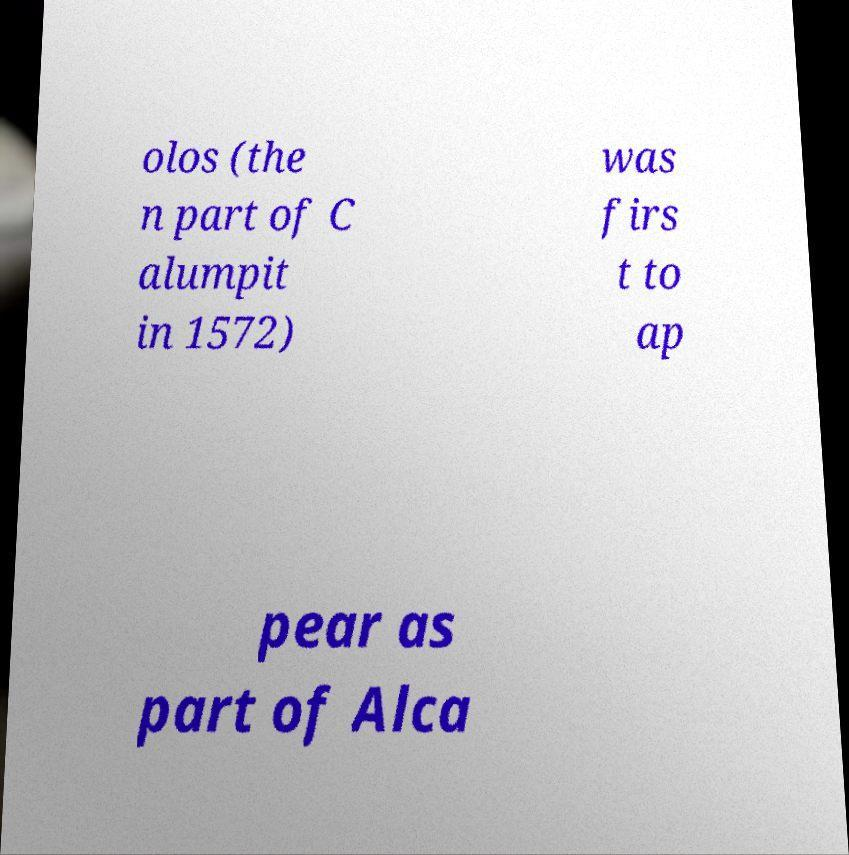For documentation purposes, I need the text within this image transcribed. Could you provide that? olos (the n part of C alumpit in 1572) was firs t to ap pear as part of Alca 